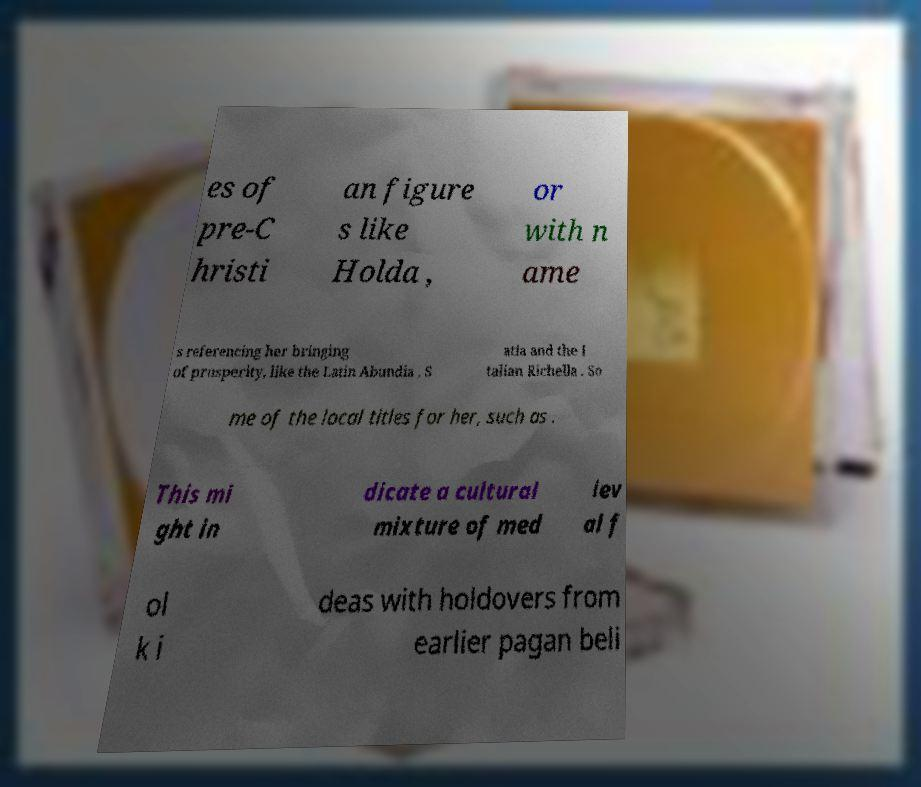Could you extract and type out the text from this image? es of pre-C hristi an figure s like Holda , or with n ame s referencing her bringing of prosperity, like the Latin Abundia , S atia and the I talian Richella . So me of the local titles for her, such as . This mi ght in dicate a cultural mixture of med iev al f ol k i deas with holdovers from earlier pagan beli 